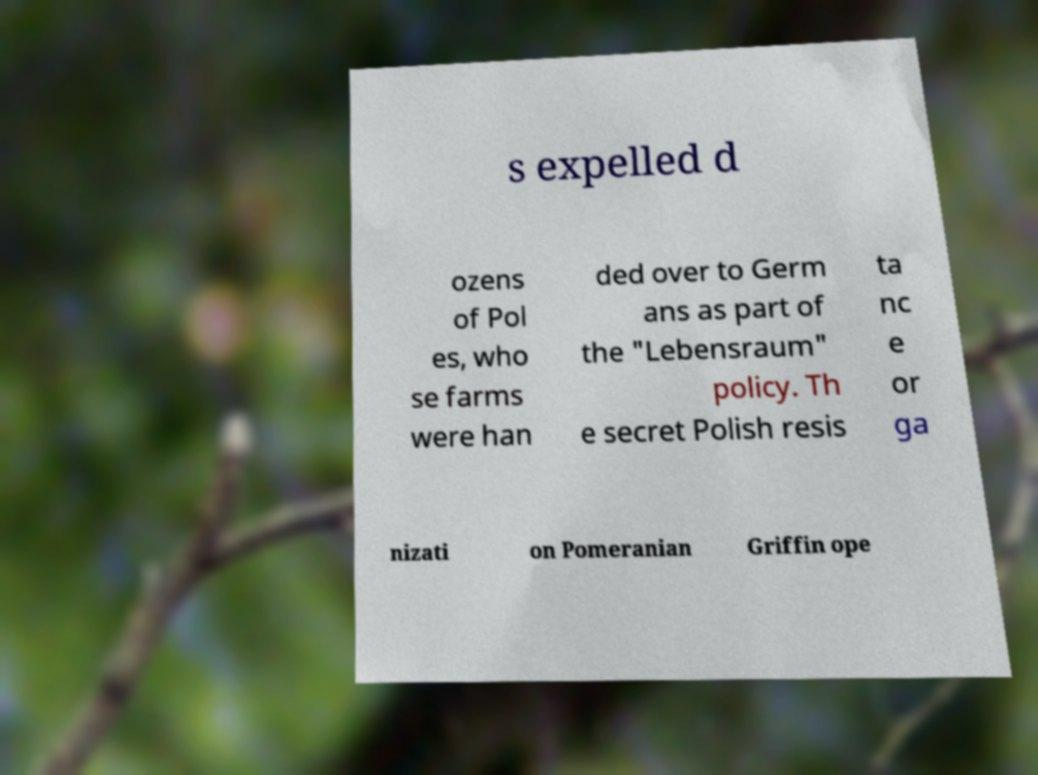Can you read and provide the text displayed in the image?This photo seems to have some interesting text. Can you extract and type it out for me? s expelled d ozens of Pol es, who se farms were han ded over to Germ ans as part of the "Lebensraum" policy. Th e secret Polish resis ta nc e or ga nizati on Pomeranian Griffin ope 